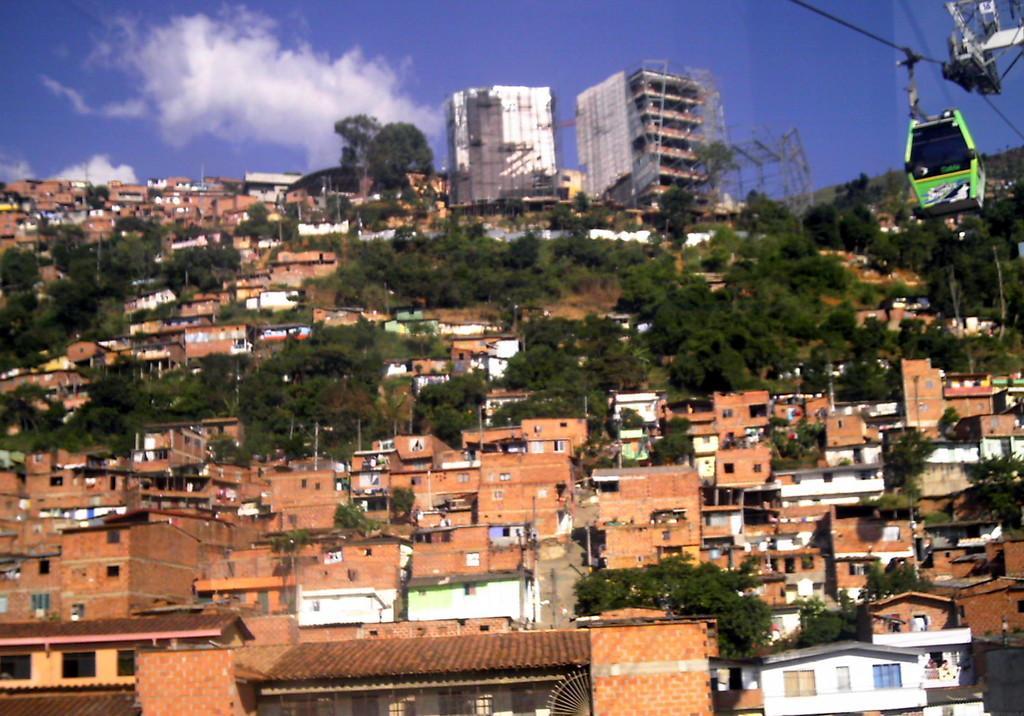Could you give a brief overview of what you see in this image? In this picture we can see buildings, trees and poles. In the background of the image we can see the sky with clouds. In the top right side of the image we can see ropeway cable car. 